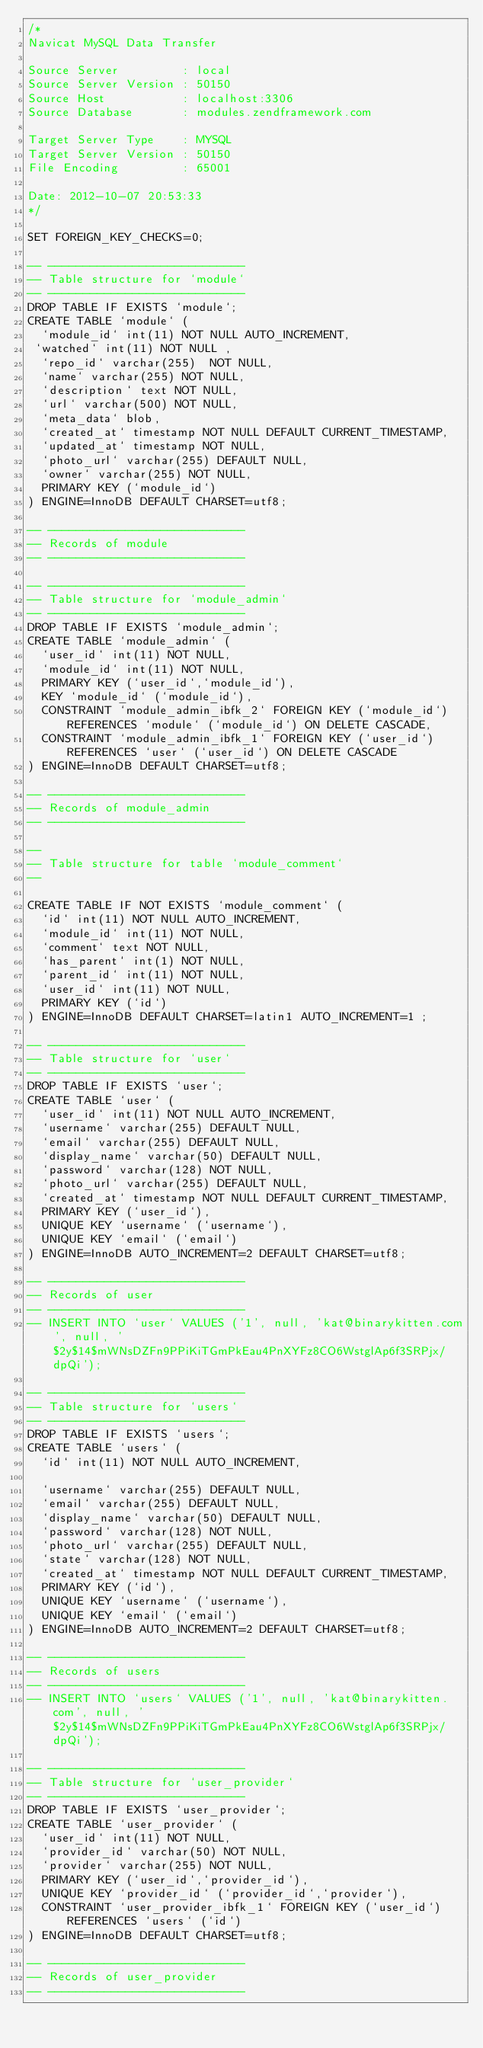<code> <loc_0><loc_0><loc_500><loc_500><_SQL_>/*
Navicat MySQL Data Transfer

Source Server         : local
Source Server Version : 50150
Source Host           : localhost:3306
Source Database       : modules.zendframework.com

Target Server Type    : MYSQL
Target Server Version : 50150
File Encoding         : 65001

Date: 2012-10-07 20:53:33
*/

SET FOREIGN_KEY_CHECKS=0;

-- ----------------------------
-- Table structure for `module`
-- ----------------------------
DROP TABLE IF EXISTS `module`;
CREATE TABLE `module` (
  `module_id` int(11) NOT NULL AUTO_INCREMENT,
 `watched` int(11) NOT NULL ,
  `repo_id` varchar(255)  NOT NULL,
  `name` varchar(255) NOT NULL,
  `description` text NOT NULL,
  `url` varchar(500) NOT NULL,
  `meta_data` blob,
  `created_at` timestamp NOT NULL DEFAULT CURRENT_TIMESTAMP,
  `updated_at` timestamp NOT NULL,
  `photo_url` varchar(255) DEFAULT NULL,
  `owner` varchar(255) NOT NULL,
  PRIMARY KEY (`module_id`)
) ENGINE=InnoDB DEFAULT CHARSET=utf8;

-- ----------------------------
-- Records of module
-- ----------------------------

-- ----------------------------
-- Table structure for `module_admin`
-- ----------------------------
DROP TABLE IF EXISTS `module_admin`;
CREATE TABLE `module_admin` (
  `user_id` int(11) NOT NULL,
  `module_id` int(11) NOT NULL,
  PRIMARY KEY (`user_id`,`module_id`),
  KEY `module_id` (`module_id`),
  CONSTRAINT `module_admin_ibfk_2` FOREIGN KEY (`module_id`) REFERENCES `module` (`module_id`) ON DELETE CASCADE,
  CONSTRAINT `module_admin_ibfk_1` FOREIGN KEY (`user_id`) REFERENCES `user` (`user_id`) ON DELETE CASCADE
) ENGINE=InnoDB DEFAULT CHARSET=utf8;

-- ----------------------------
-- Records of module_admin
-- ----------------------------

--
-- Table structure for table `module_comment`
--

CREATE TABLE IF NOT EXISTS `module_comment` (
  `id` int(11) NOT NULL AUTO_INCREMENT,
  `module_id` int(11) NOT NULL,
  `comment` text NOT NULL,
  `has_parent` int(1) NOT NULL,
  `parent_id` int(11) NOT NULL,
  `user_id` int(11) NOT NULL,
  PRIMARY KEY (`id`)
) ENGINE=InnoDB DEFAULT CHARSET=latin1 AUTO_INCREMENT=1 ;

-- ----------------------------
-- Table structure for `user`
-- ----------------------------
DROP TABLE IF EXISTS `user`;
CREATE TABLE `user` (
  `user_id` int(11) NOT NULL AUTO_INCREMENT,
  `username` varchar(255) DEFAULT NULL,
  `email` varchar(255) DEFAULT NULL,
  `display_name` varchar(50) DEFAULT NULL,
  `password` varchar(128) NOT NULL,
  `photo_url` varchar(255) DEFAULT NULL,
  `created_at` timestamp NOT NULL DEFAULT CURRENT_TIMESTAMP,
  PRIMARY KEY (`user_id`),
  UNIQUE KEY `username` (`username`),
  UNIQUE KEY `email` (`email`)
) ENGINE=InnoDB AUTO_INCREMENT=2 DEFAULT CHARSET=utf8;

-- ----------------------------
-- Records of user
-- ----------------------------
-- INSERT INTO `user` VALUES ('1', null, 'kat@binarykitten.com', null, '$2y$14$mWNsDZFn9PPiKiTGmPkEau4PnXYFz8CO6WstglAp6f3SRPjx/dpQi');

-- ----------------------------
-- Table structure for `users`
-- ----------------------------
DROP TABLE IF EXISTS `users`;
CREATE TABLE `users` (
  `id` int(11) NOT NULL AUTO_INCREMENT,

  `username` varchar(255) DEFAULT NULL,
  `email` varchar(255) DEFAULT NULL,
  `display_name` varchar(50) DEFAULT NULL,
  `password` varchar(128) NOT NULL,
  `photo_url` varchar(255) DEFAULT NULL,
  `state` varchar(128) NOT NULL,
  `created_at` timestamp NOT NULL DEFAULT CURRENT_TIMESTAMP,
  PRIMARY KEY (`id`),
  UNIQUE KEY `username` (`username`),
  UNIQUE KEY `email` (`email`)
) ENGINE=InnoDB AUTO_INCREMENT=2 DEFAULT CHARSET=utf8;

-- ----------------------------
-- Records of users
-- ----------------------------
-- INSERT INTO `users` VALUES ('1', null, 'kat@binarykitten.com', null, '$2y$14$mWNsDZFn9PPiKiTGmPkEau4PnXYFz8CO6WstglAp6f3SRPjx/dpQi');

-- ----------------------------
-- Table structure for `user_provider`
-- ----------------------------
DROP TABLE IF EXISTS `user_provider`;
CREATE TABLE `user_provider` (
  `user_id` int(11) NOT NULL,
  `provider_id` varchar(50) NOT NULL,
  `provider` varchar(255) NOT NULL,
  PRIMARY KEY (`user_id`,`provider_id`),
  UNIQUE KEY `provider_id` (`provider_id`,`provider`),
  CONSTRAINT `user_provider_ibfk_1` FOREIGN KEY (`user_id`) REFERENCES `users` (`id`)
) ENGINE=InnoDB DEFAULT CHARSET=utf8;

-- ----------------------------
-- Records of user_provider
-- ----------------------------
</code> 